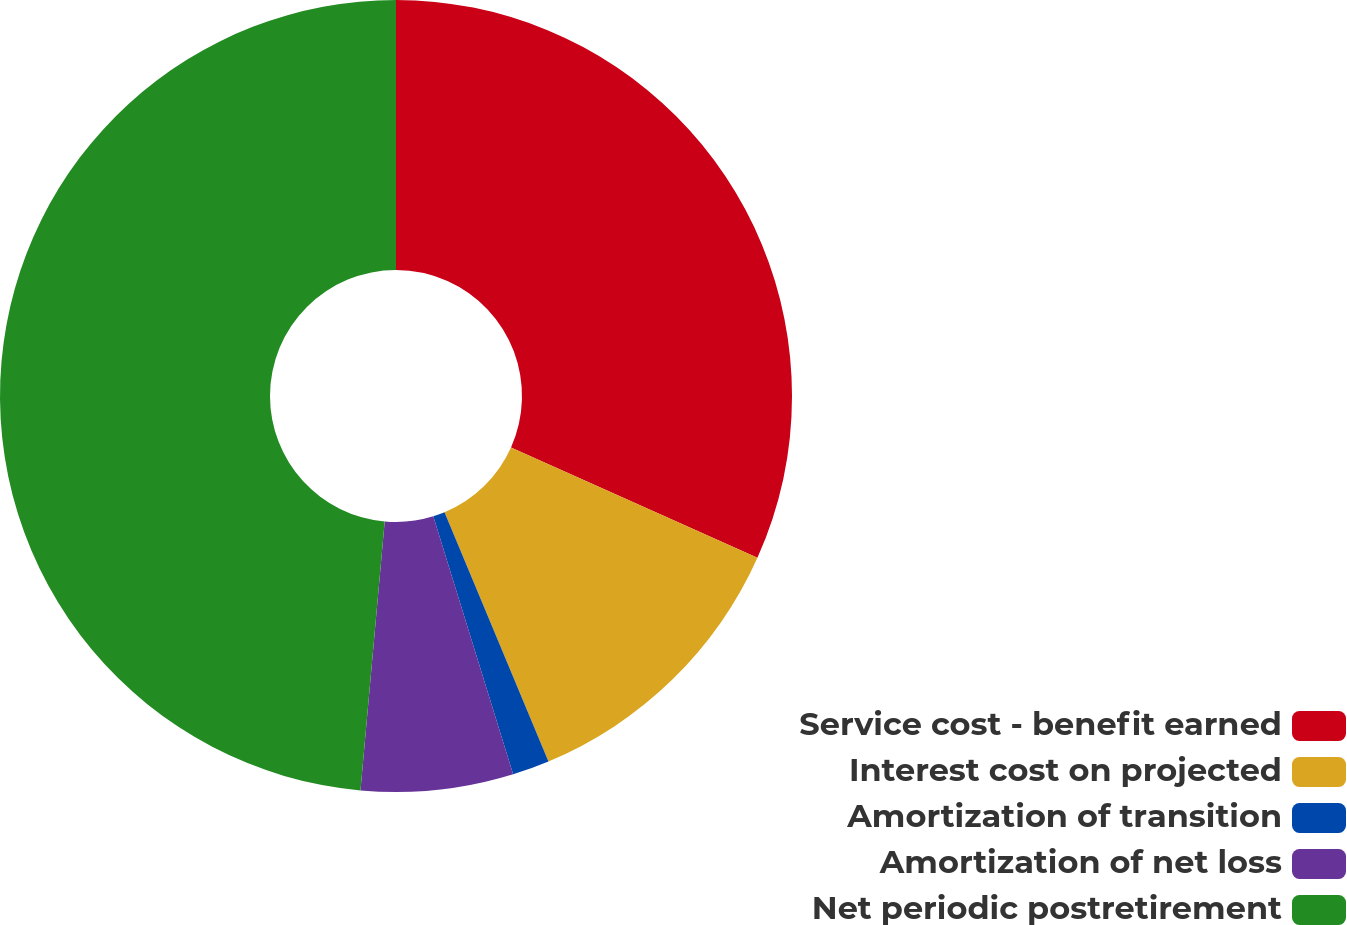Convert chart to OTSL. <chart><loc_0><loc_0><loc_500><loc_500><pie_chart><fcel>Service cost - benefit earned<fcel>Interest cost on projected<fcel>Amortization of transition<fcel>Amortization of net loss<fcel>Net periodic postretirement<nl><fcel>31.7%<fcel>12.01%<fcel>1.51%<fcel>6.21%<fcel>48.57%<nl></chart> 